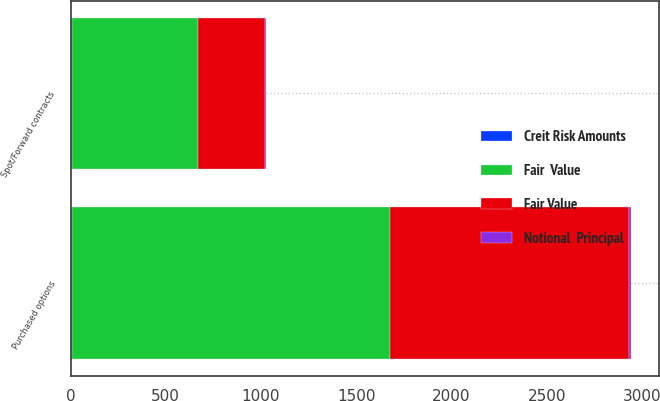<chart> <loc_0><loc_0><loc_500><loc_500><stacked_bar_chart><ecel><fcel>Spot/Forward contracts<fcel>Purchased options<nl><fcel>Fair Value<fcel>351<fcel>1256<nl><fcel>Creit Risk Amounts<fcel>6<fcel>9<nl><fcel>Notional  Principal<fcel>6<fcel>9<nl><fcel>Fair  Value<fcel>662<fcel>1668<nl></chart> 